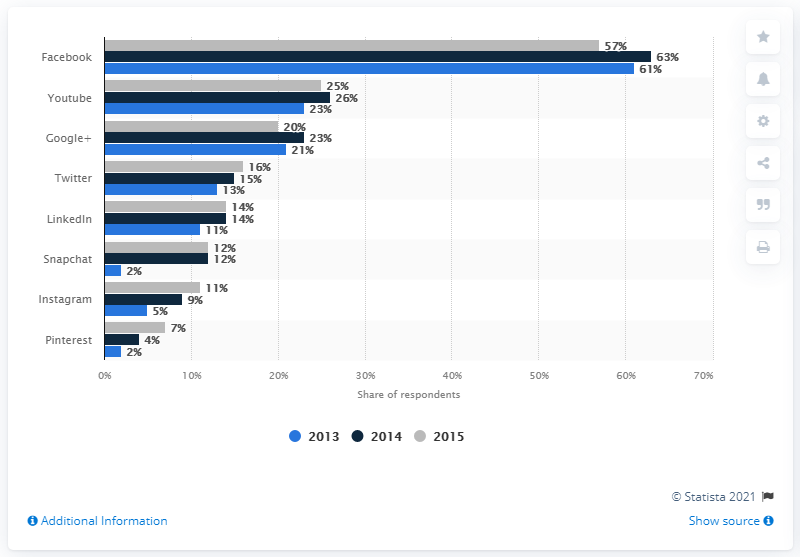Mention a couple of crucial points in this snapshot. According to a recent survey, 12% of French internet users have used Snapchat in the last 30 days, making it the most popular social networking platform in the country. 